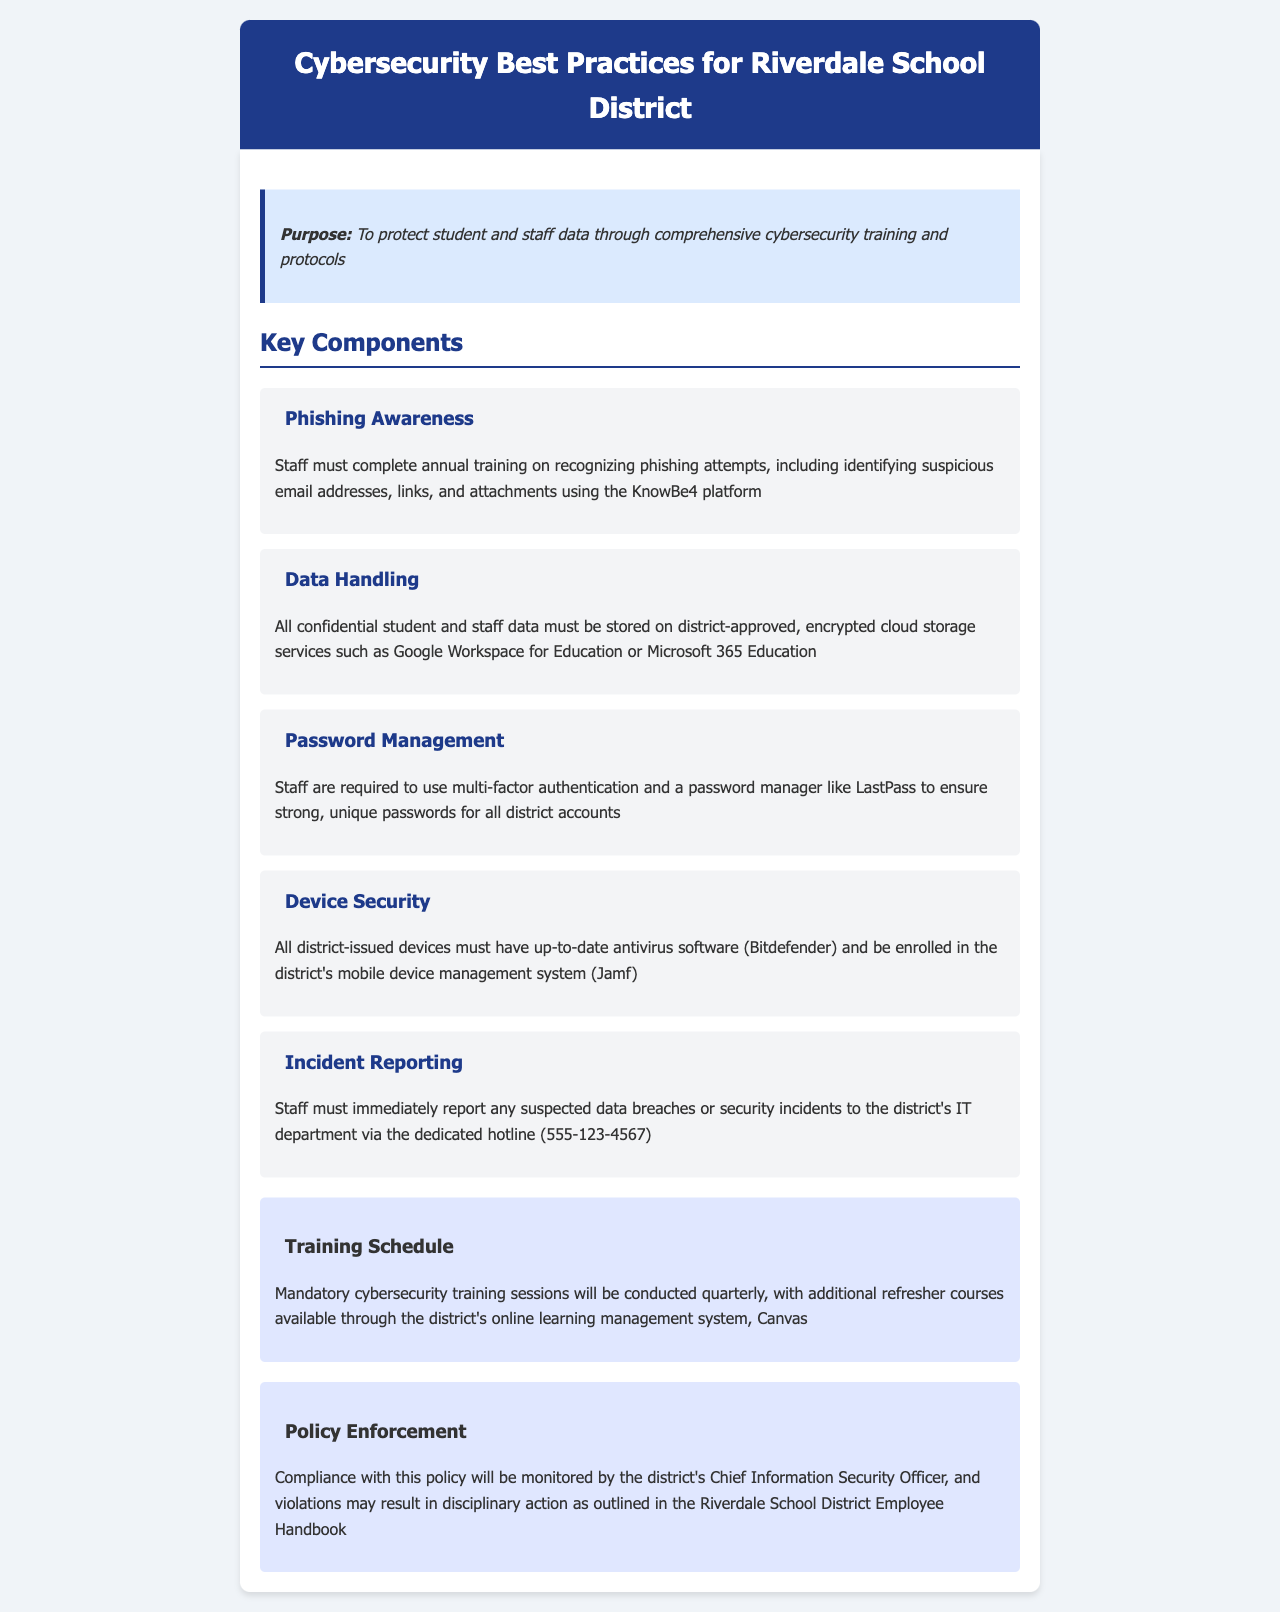What is the purpose of the document? The purpose of the document is outlined in the purpose section, which is to protect student and staff data through comprehensive cybersecurity training and protocols.
Answer: To protect student and staff data How often must staff complete phishing awareness training? The document states that staff must complete annual training on recognizing phishing attempts.
Answer: Annual What platform is used for phishing training? The document mentions that the KnowBe4 platform is utilized for phishing training.
Answer: KnowBe4 What type of storage must confidential data be kept on? The policy specifies that confidential data must be stored on district-approved, encrypted cloud storage services.
Answer: Encrypted cloud storage What software is mandatory on district-issued devices? The document requires that district-issued devices must have up-to-date antivirus software.
Answer: Up-to-date antivirus software How frequently are mandatory cybersecurity training sessions held? The document states that the mandatory cybersecurity training sessions will be conducted quarterly.
Answer: Quarterly Who is responsible for monitoring compliance with this policy? The document indicates that compliance will be monitored by the district's Chief Information Security Officer.
Answer: Chief Information Security Officer What should staff do if they suspect a data breach? The policy states that staff must immediately report any suspected data breaches or security incidents.
Answer: Report immediately What is the hotline number for reporting incidents? The document provides the dedicated hotline number for reporting incidents as 555-123-4567.
Answer: 555-123-4567 